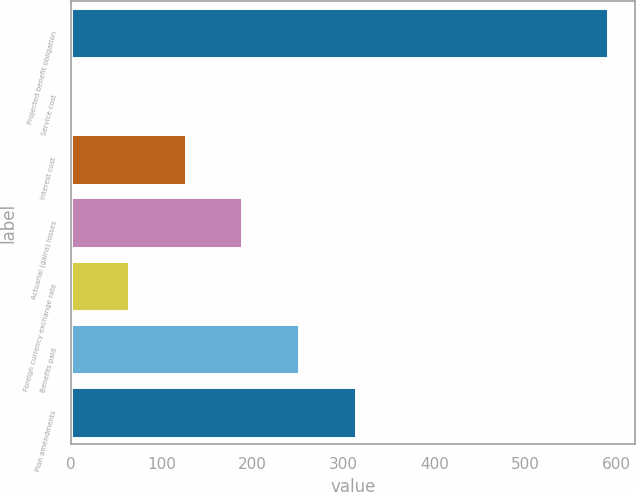<chart> <loc_0><loc_0><loc_500><loc_500><bar_chart><fcel>Projected benefit obligation<fcel>Service cost<fcel>Interest cost<fcel>Actuarial (gains) losses<fcel>Foreign currency exchange rate<fcel>Benefits paid<fcel>Plan amendments<nl><fcel>591<fcel>2<fcel>126.6<fcel>188.9<fcel>64.3<fcel>251.2<fcel>313.5<nl></chart> 